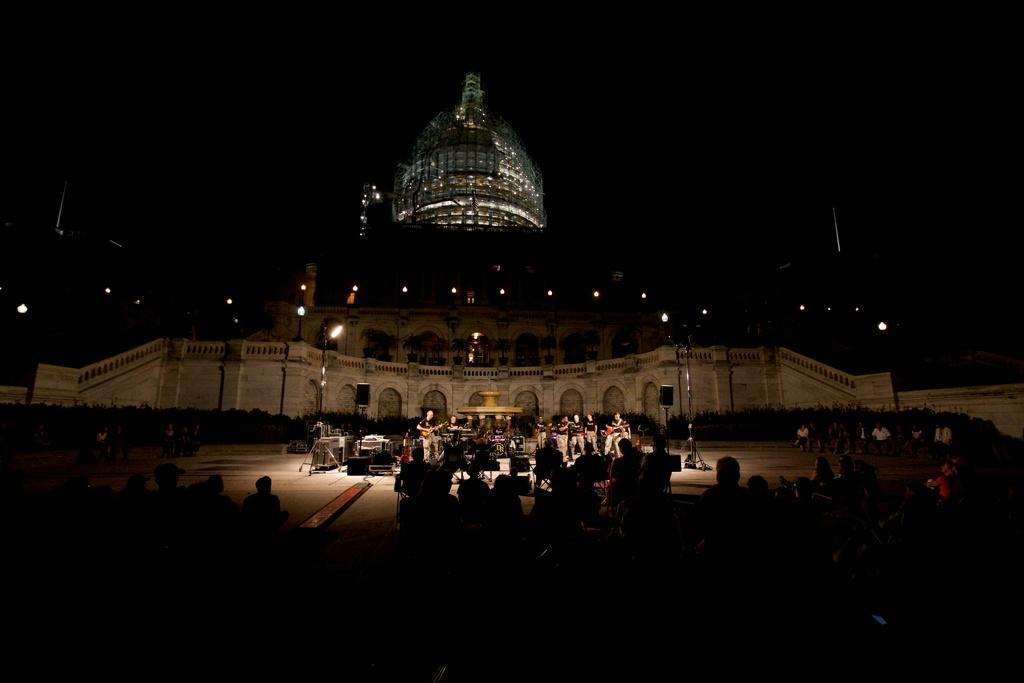Describe this image in one or two sentences. In this image there are group of persons, and at the background there are musical instruments, a water sculpture fountain ,group of persons standing, trees, lights, building, sky. 